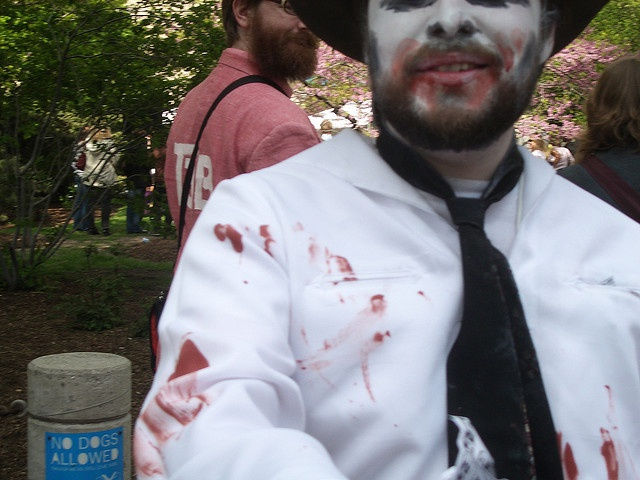Describe the objects in this image and their specific colors. I can see people in black, lavender, and darkgray tones, tie in black, gray, and darkgray tones, people in black, brown, and maroon tones, people in black and gray tones, and handbag in black, brown, and maroon tones in this image. 